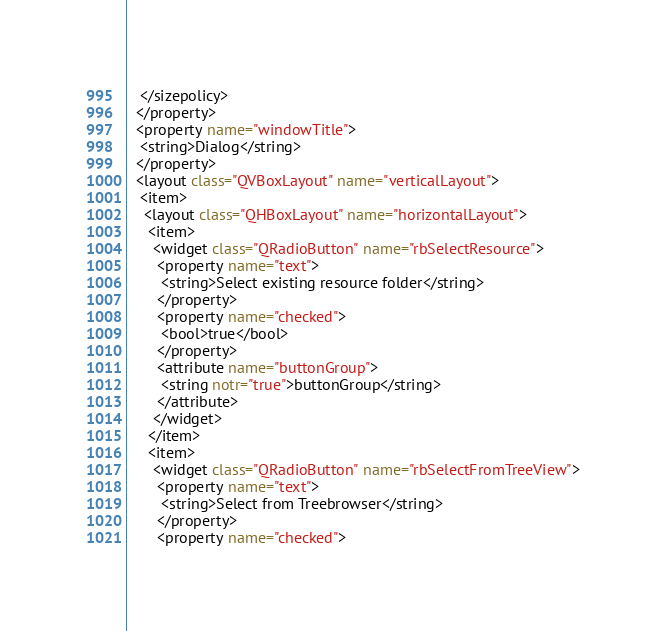<code> <loc_0><loc_0><loc_500><loc_500><_XML_>   </sizepolicy>
  </property>
  <property name="windowTitle">
   <string>Dialog</string>
  </property>
  <layout class="QVBoxLayout" name="verticalLayout">
   <item>
    <layout class="QHBoxLayout" name="horizontalLayout">
     <item>
      <widget class="QRadioButton" name="rbSelectResource">
       <property name="text">
        <string>Select existing resource folder</string>
       </property>
       <property name="checked">
        <bool>true</bool>
       </property>
       <attribute name="buttonGroup">
        <string notr="true">buttonGroup</string>
       </attribute>
      </widget>
     </item>
     <item>
      <widget class="QRadioButton" name="rbSelectFromTreeView">
       <property name="text">
        <string>Select from Treebrowser</string>
       </property>
       <property name="checked"></code> 